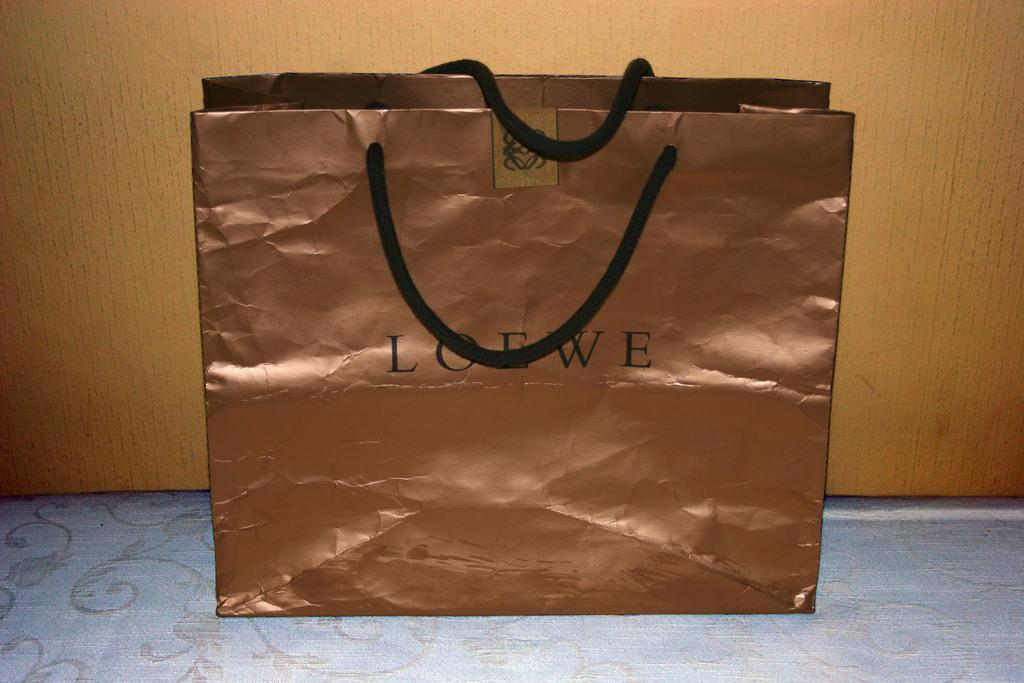What object can be seen in the image? There is a bag in the image. How many jellyfish are swimming in the bag in the image? There are no jellyfish present in the image; it only features a bag. 